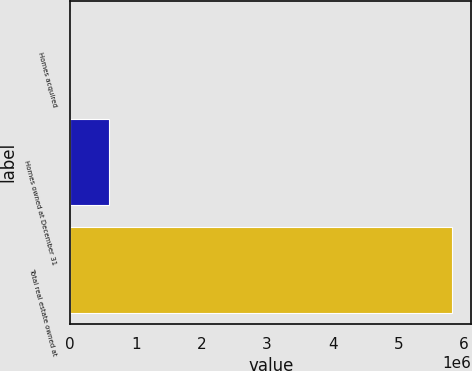Convert chart to OTSL. <chart><loc_0><loc_0><loc_500><loc_500><bar_chart><fcel>Homes acquired<fcel>Homes owned at December 31<fcel>Total real estate owned at<nl><fcel>2763<fcel>584499<fcel>5.82012e+06<nl></chart> 